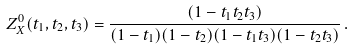Convert formula to latex. <formula><loc_0><loc_0><loc_500><loc_500>Z ^ { 0 } _ { X } ( t _ { 1 } , t _ { 2 } , t _ { 3 } ) = \frac { ( 1 - t _ { 1 } t _ { 2 } t _ { 3 } ) } { ( 1 - t _ { 1 } ) ( 1 - t _ { 2 } ) ( 1 - t _ { 1 } t _ { 3 } ) ( 1 - t _ { 2 } t _ { 3 } ) } \, .</formula> 